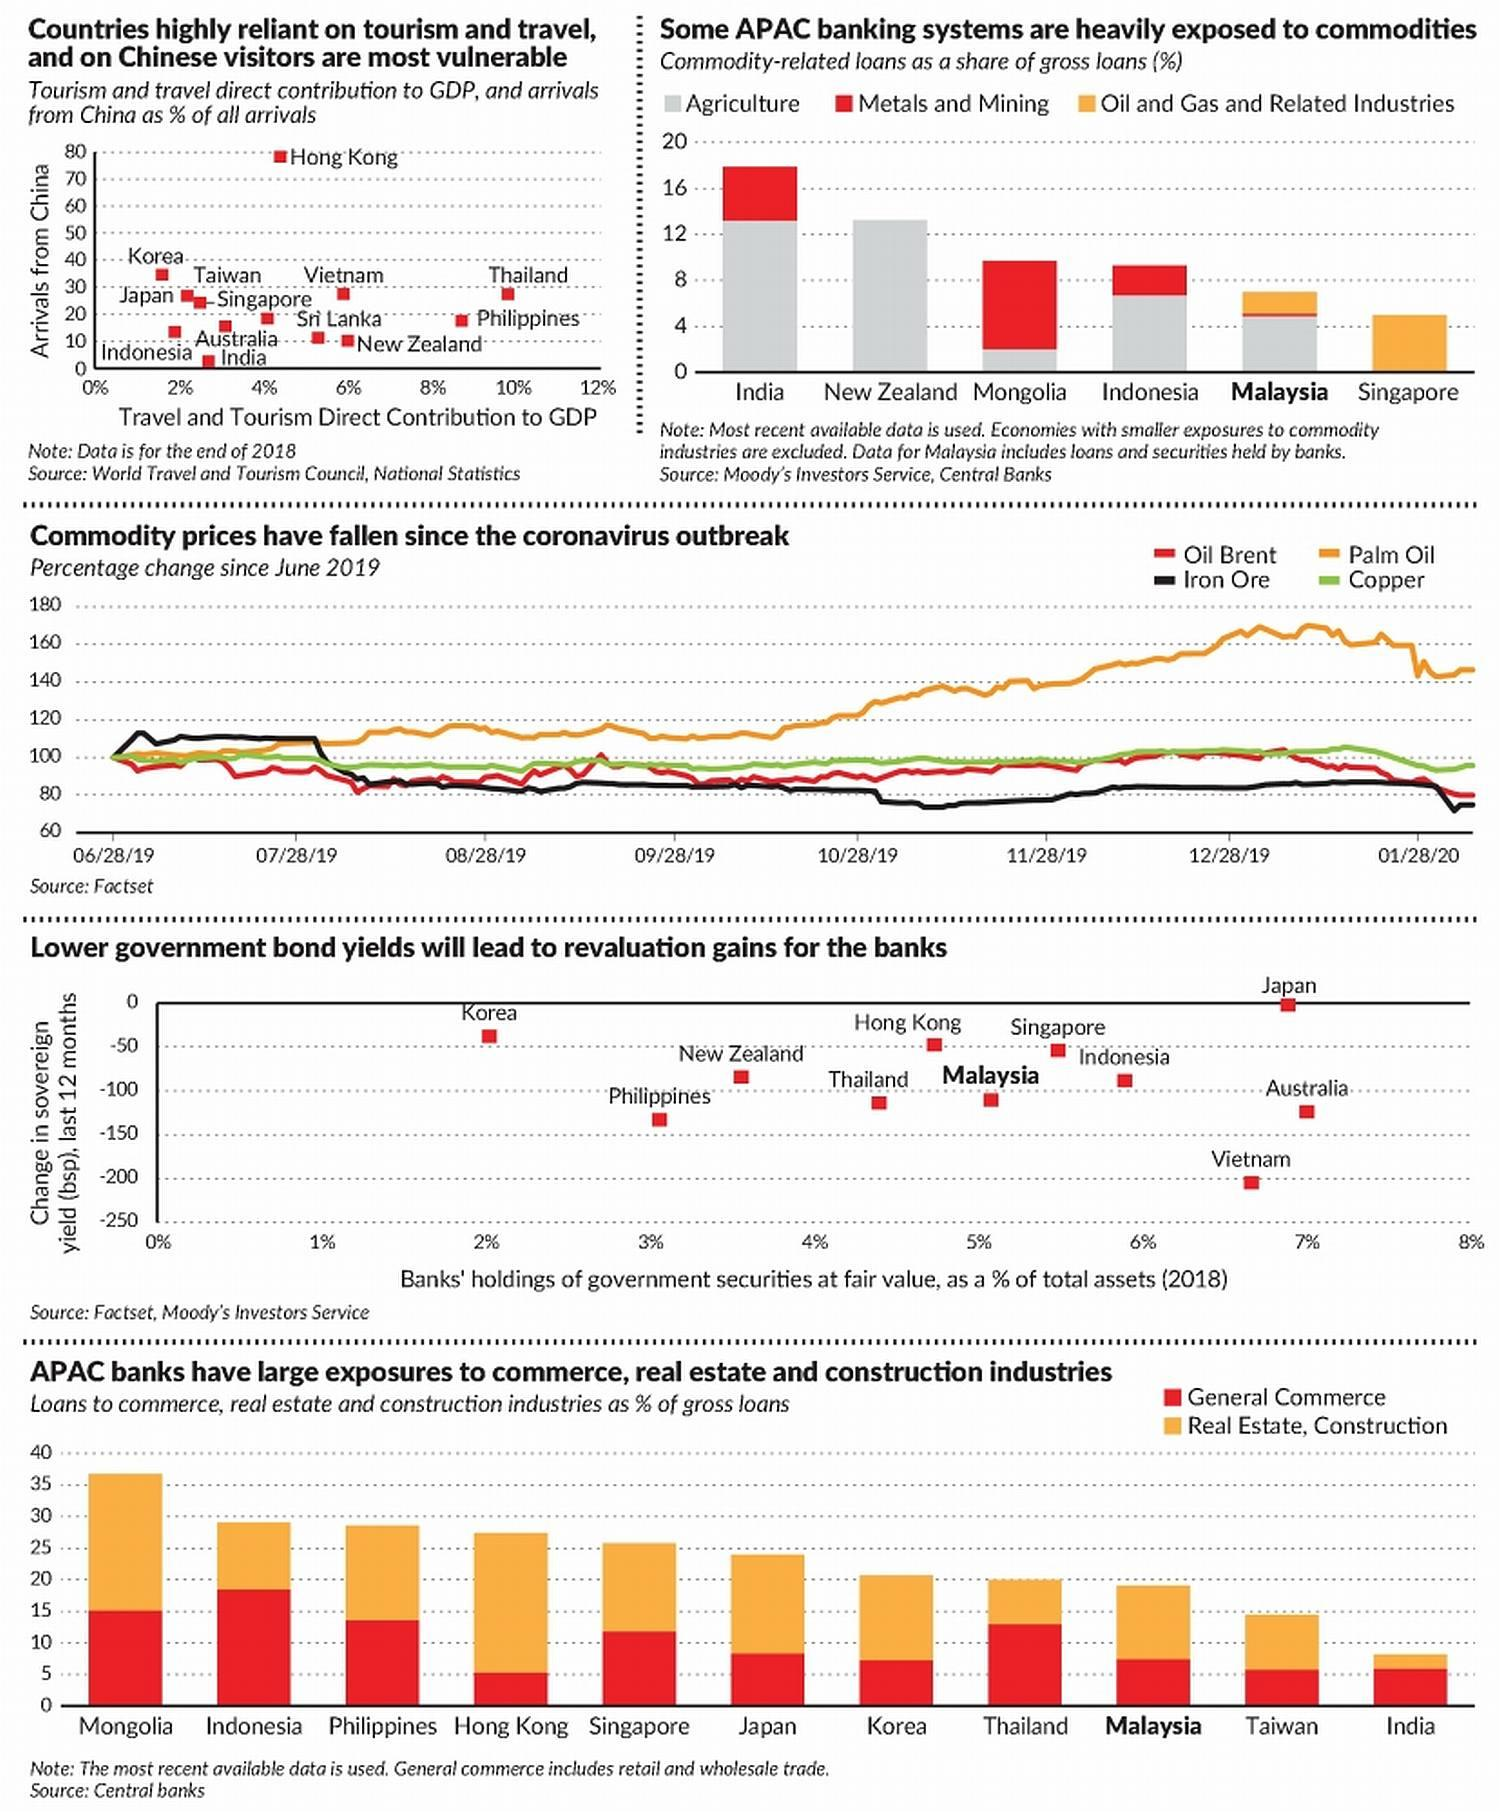List a handful of essential elements in this visual. The color used to plot "Palm Oil" is orange. There are 5 graphs included in this infographic. According to data, Thailand is among the countries that travel and tourism contribute the highest to its Gross Domestic Product (GDP). 